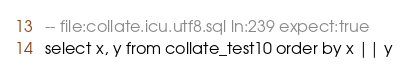Convert code to text. <code><loc_0><loc_0><loc_500><loc_500><_SQL_>-- file:collate.icu.utf8.sql ln:239 expect:true
select x, y from collate_test10 order by x || y
</code> 